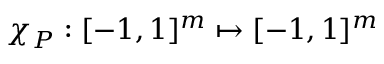<formula> <loc_0><loc_0><loc_500><loc_500>\chi _ { P } \colon [ - 1 , 1 ] ^ { m } \mapsto [ - 1 , 1 ] ^ { m }</formula> 